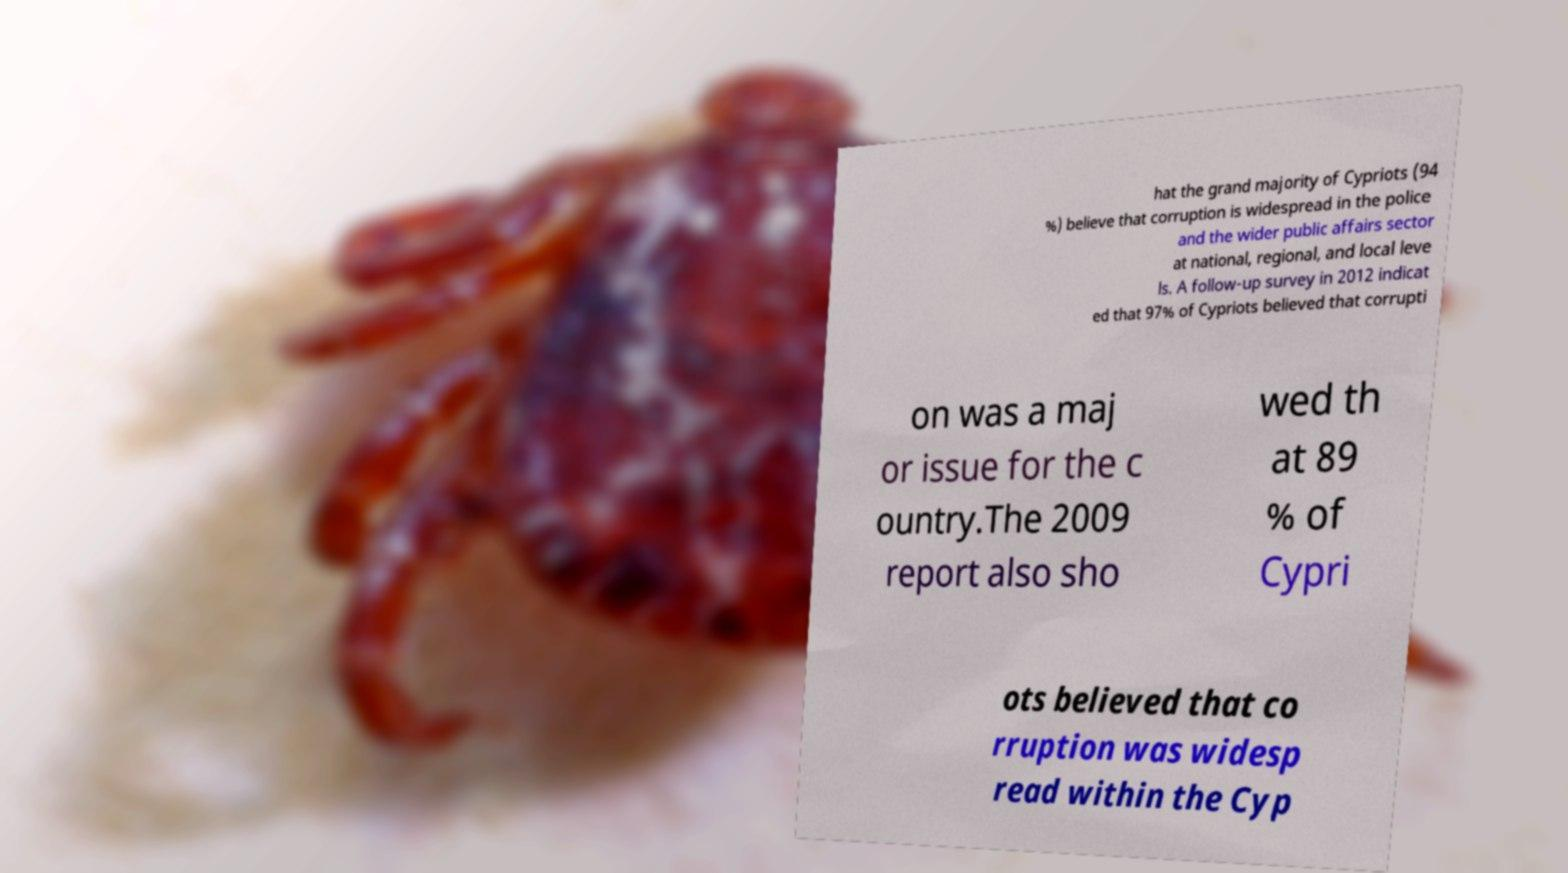Can you accurately transcribe the text from the provided image for me? hat the grand majority of Cypriots (94 %) believe that corruption is widespread in the police and the wider public affairs sector at national, regional, and local leve ls. A follow-up survey in 2012 indicat ed that 97% of Cypriots believed that corrupti on was a maj or issue for the c ountry.The 2009 report also sho wed th at 89 % of Cypri ots believed that co rruption was widesp read within the Cyp 